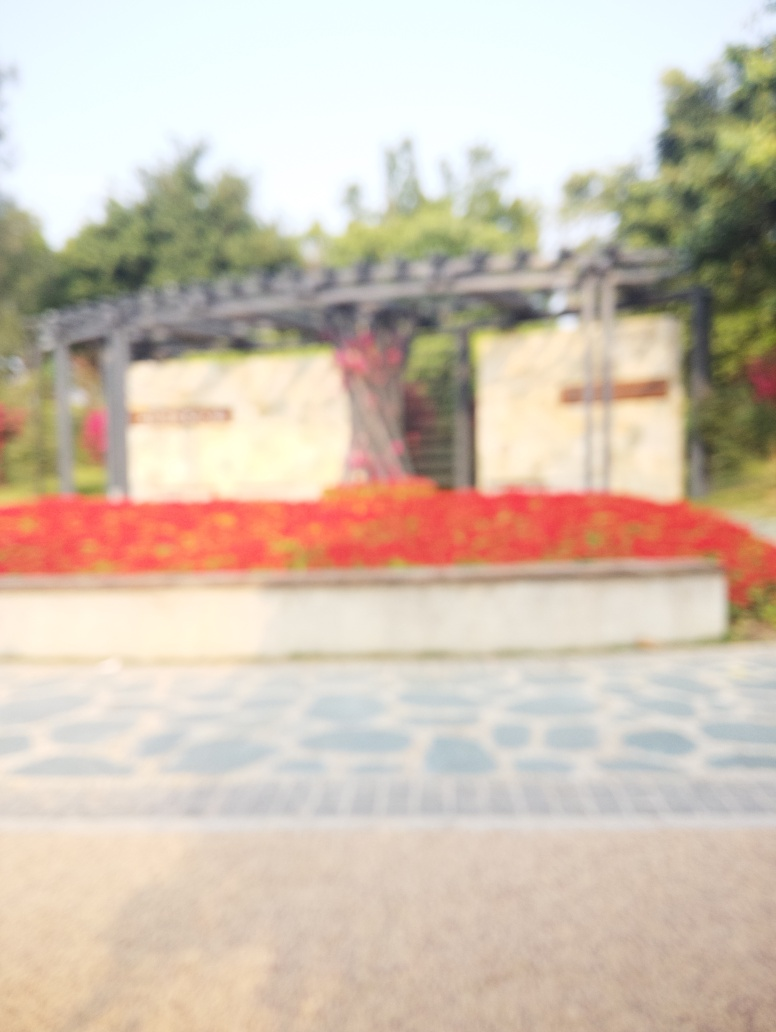Is there any writing or signage that can provide more information about this place? Due to the image being out of focus, any text that might be present on signage or structures within the image cannot be discerned reliably. 